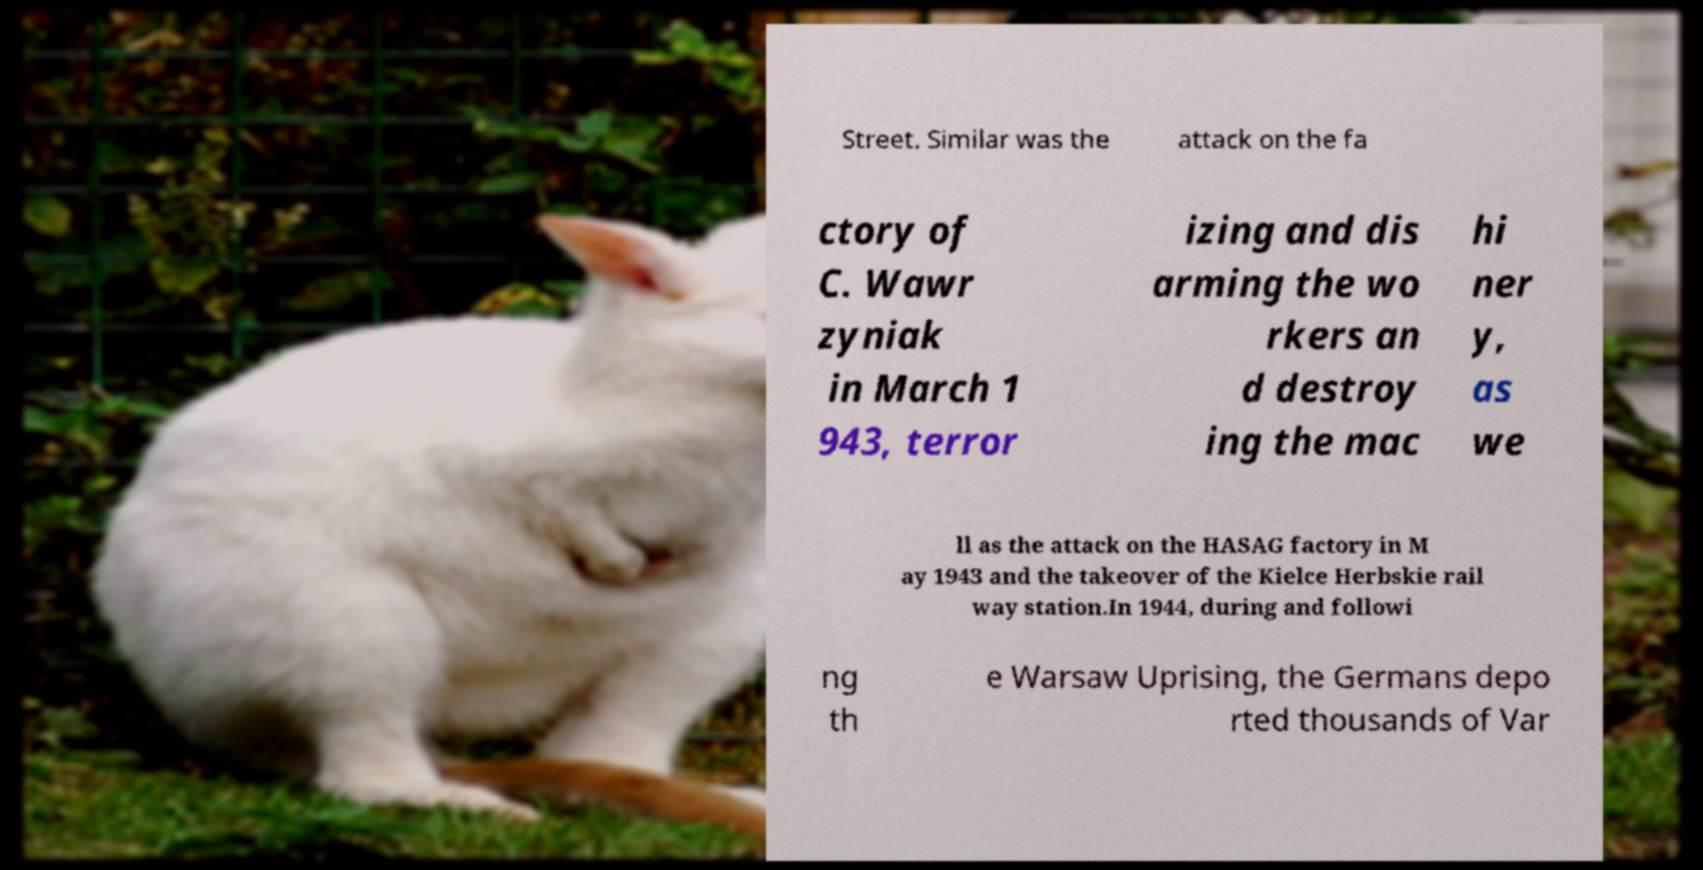I need the written content from this picture converted into text. Can you do that? Street. Similar was the attack on the fa ctory of C. Wawr zyniak in March 1 943, terror izing and dis arming the wo rkers an d destroy ing the mac hi ner y, as we ll as the attack on the HASAG factory in M ay 1943 and the takeover of the Kielce Herbskie rail way station.In 1944, during and followi ng th e Warsaw Uprising, the Germans depo rted thousands of Var 